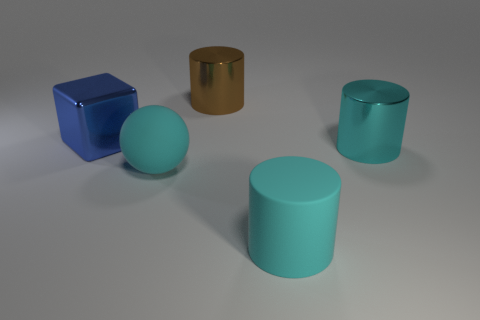Subtract all big rubber cylinders. How many cylinders are left? 2 Add 4 big blue objects. How many objects exist? 9 Subtract all cyan cylinders. How many cylinders are left? 1 Subtract 1 cylinders. How many cylinders are left? 2 Subtract all brown balls. How many cyan cylinders are left? 2 Add 5 large balls. How many large balls are left? 6 Add 4 tiny purple shiny blocks. How many tiny purple shiny blocks exist? 4 Subtract 1 brown cylinders. How many objects are left? 4 Subtract all cylinders. How many objects are left? 2 Subtract all purple balls. Subtract all brown cylinders. How many balls are left? 1 